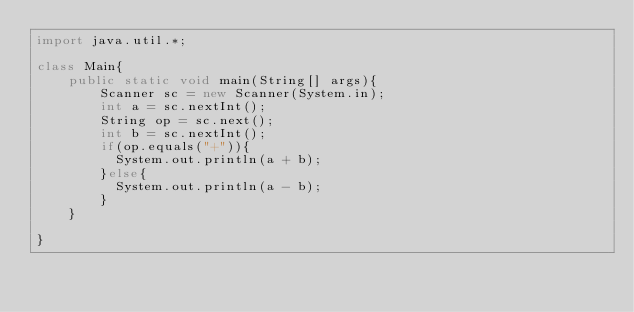<code> <loc_0><loc_0><loc_500><loc_500><_Java_>import java.util.*;
 
class Main{
	public static void main(String[] args){
    	Scanner sc = new Scanner(System.in);
      	int a = sc.nextInt();
      	String op = sc.next();
      	int b = sc.nextInt();
      	if(op.equals("+")){
          System.out.println(a + b);
        }else{
          System.out.println(a - b);
        }
    }
  
}</code> 